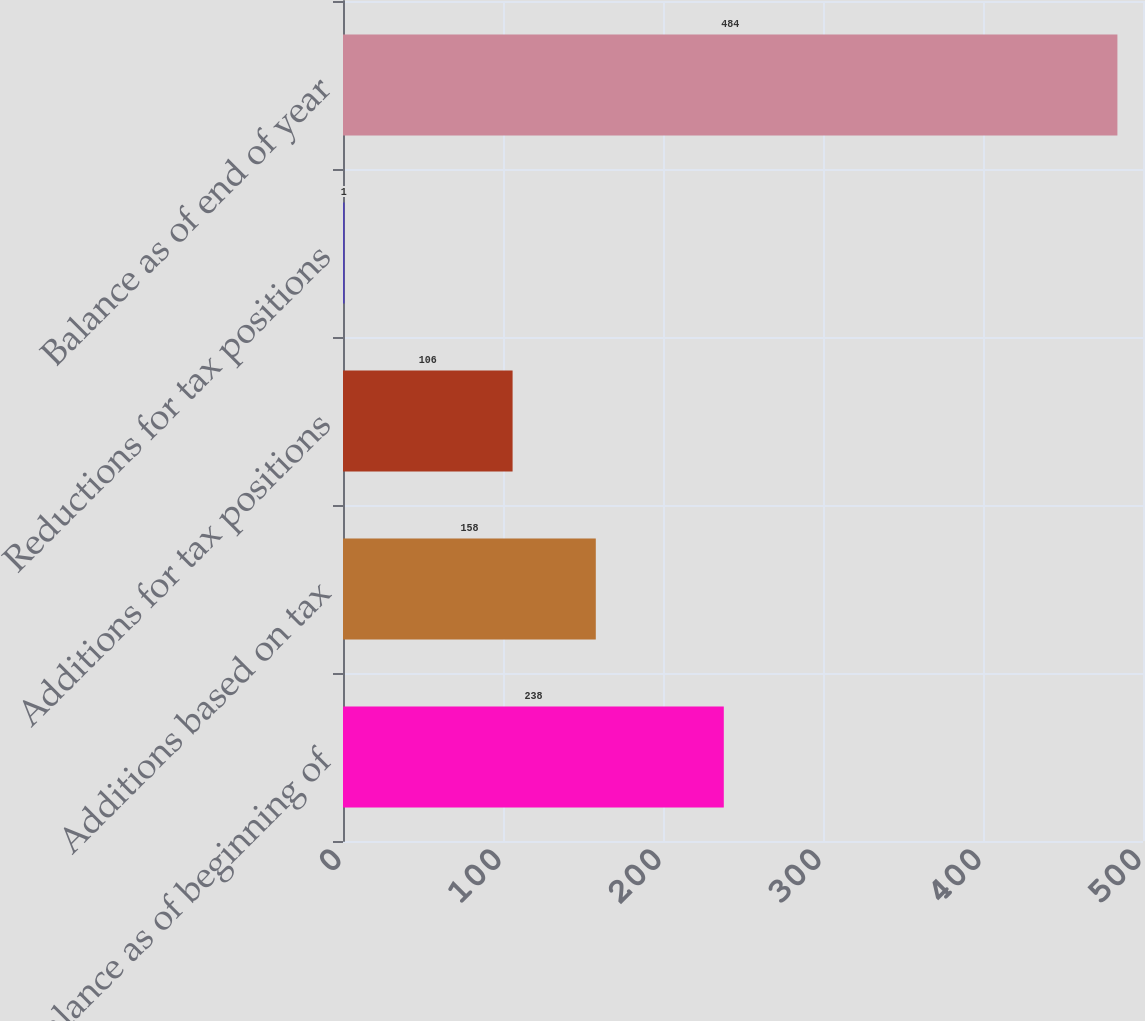<chart> <loc_0><loc_0><loc_500><loc_500><bar_chart><fcel>Balance as of beginning of<fcel>Additions based on tax<fcel>Additions for tax positions<fcel>Reductions for tax positions<fcel>Balance as of end of year<nl><fcel>238<fcel>158<fcel>106<fcel>1<fcel>484<nl></chart> 